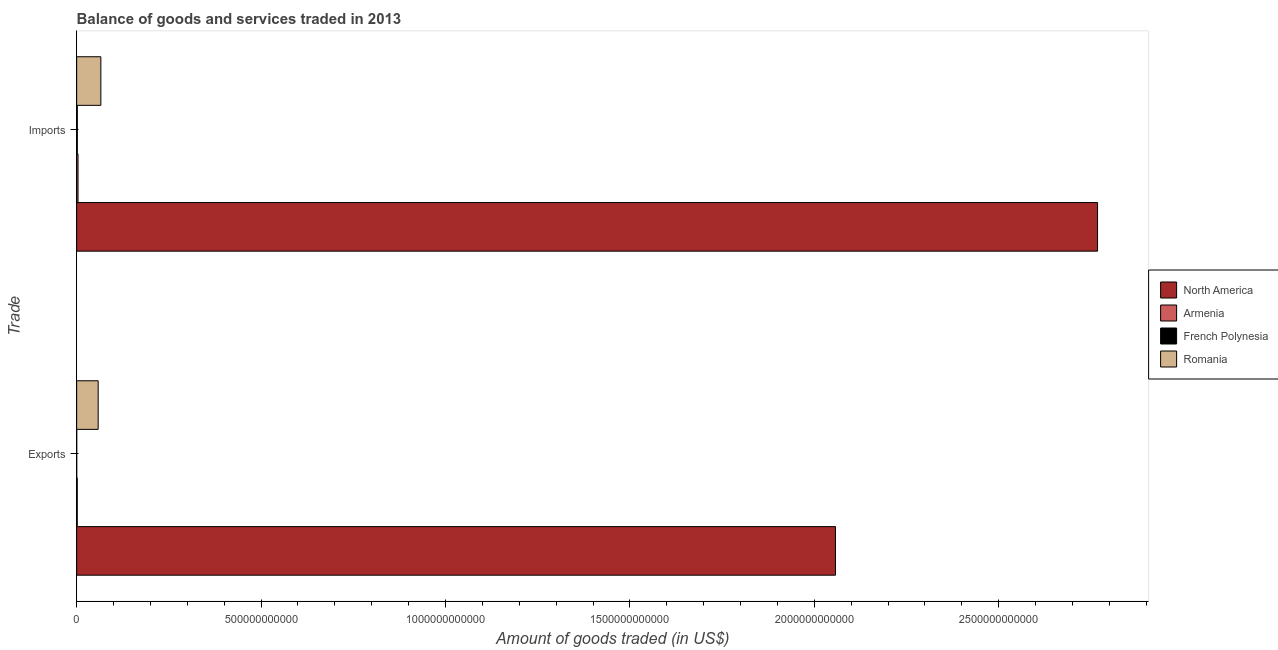Are the number of bars per tick equal to the number of legend labels?
Offer a very short reply. Yes. Are the number of bars on each tick of the Y-axis equal?
Your answer should be very brief. Yes. What is the label of the 2nd group of bars from the top?
Offer a very short reply. Exports. What is the amount of goods imported in Romania?
Offer a very short reply. 6.56e+1. Across all countries, what is the maximum amount of goods exported?
Provide a succinct answer. 2.06e+12. Across all countries, what is the minimum amount of goods exported?
Give a very brief answer. 1.50e+08. In which country was the amount of goods exported minimum?
Your answer should be very brief. French Polynesia. What is the total amount of goods imported in the graph?
Provide a succinct answer. 2.84e+12. What is the difference between the amount of goods exported in Romania and that in North America?
Provide a short and direct response. -2.00e+12. What is the difference between the amount of goods exported in Romania and the amount of goods imported in French Polynesia?
Your response must be concise. 5.65e+1. What is the average amount of goods exported per country?
Offer a very short reply. 5.29e+11. What is the difference between the amount of goods imported and amount of goods exported in Romania?
Make the answer very short. 7.24e+09. In how many countries, is the amount of goods imported greater than 1700000000000 US$?
Make the answer very short. 1. What is the ratio of the amount of goods imported in French Polynesia to that in Armenia?
Give a very brief answer. 0.48. What does the 2nd bar from the top in Imports represents?
Your answer should be compact. French Polynesia. How many bars are there?
Provide a short and direct response. 8. What is the difference between two consecutive major ticks on the X-axis?
Your response must be concise. 5.00e+11. Are the values on the major ticks of X-axis written in scientific E-notation?
Your response must be concise. No. Does the graph contain grids?
Provide a short and direct response. No. Where does the legend appear in the graph?
Ensure brevity in your answer.  Center right. How many legend labels are there?
Your answer should be very brief. 4. What is the title of the graph?
Make the answer very short. Balance of goods and services traded in 2013. What is the label or title of the X-axis?
Your answer should be very brief. Amount of goods traded (in US$). What is the label or title of the Y-axis?
Ensure brevity in your answer.  Trade. What is the Amount of goods traded (in US$) in North America in Exports?
Your answer should be very brief. 2.06e+12. What is the Amount of goods traded (in US$) in Armenia in Exports?
Keep it short and to the point. 1.64e+09. What is the Amount of goods traded (in US$) in French Polynesia in Exports?
Your response must be concise. 1.50e+08. What is the Amount of goods traded (in US$) in Romania in Exports?
Keep it short and to the point. 5.83e+1. What is the Amount of goods traded (in US$) of North America in Imports?
Offer a very short reply. 2.77e+12. What is the Amount of goods traded (in US$) in Armenia in Imports?
Offer a terse response. 3.73e+09. What is the Amount of goods traded (in US$) of French Polynesia in Imports?
Provide a succinct answer. 1.78e+09. What is the Amount of goods traded (in US$) of Romania in Imports?
Ensure brevity in your answer.  6.56e+1. Across all Trade, what is the maximum Amount of goods traded (in US$) in North America?
Provide a succinct answer. 2.77e+12. Across all Trade, what is the maximum Amount of goods traded (in US$) of Armenia?
Give a very brief answer. 3.73e+09. Across all Trade, what is the maximum Amount of goods traded (in US$) of French Polynesia?
Give a very brief answer. 1.78e+09. Across all Trade, what is the maximum Amount of goods traded (in US$) of Romania?
Offer a very short reply. 6.56e+1. Across all Trade, what is the minimum Amount of goods traded (in US$) of North America?
Your response must be concise. 2.06e+12. Across all Trade, what is the minimum Amount of goods traded (in US$) in Armenia?
Ensure brevity in your answer.  1.64e+09. Across all Trade, what is the minimum Amount of goods traded (in US$) of French Polynesia?
Ensure brevity in your answer.  1.50e+08. Across all Trade, what is the minimum Amount of goods traded (in US$) in Romania?
Offer a terse response. 5.83e+1. What is the total Amount of goods traded (in US$) in North America in the graph?
Your answer should be very brief. 4.83e+12. What is the total Amount of goods traded (in US$) of Armenia in the graph?
Give a very brief answer. 5.36e+09. What is the total Amount of goods traded (in US$) in French Polynesia in the graph?
Keep it short and to the point. 1.93e+09. What is the total Amount of goods traded (in US$) in Romania in the graph?
Your response must be concise. 1.24e+11. What is the difference between the Amount of goods traded (in US$) in North America in Exports and that in Imports?
Offer a terse response. -7.11e+11. What is the difference between the Amount of goods traded (in US$) in Armenia in Exports and that in Imports?
Make the answer very short. -2.09e+09. What is the difference between the Amount of goods traded (in US$) in French Polynesia in Exports and that in Imports?
Ensure brevity in your answer.  -1.63e+09. What is the difference between the Amount of goods traded (in US$) of Romania in Exports and that in Imports?
Offer a very short reply. -7.24e+09. What is the difference between the Amount of goods traded (in US$) in North America in Exports and the Amount of goods traded (in US$) in Armenia in Imports?
Make the answer very short. 2.05e+12. What is the difference between the Amount of goods traded (in US$) in North America in Exports and the Amount of goods traded (in US$) in French Polynesia in Imports?
Offer a very short reply. 2.06e+12. What is the difference between the Amount of goods traded (in US$) in North America in Exports and the Amount of goods traded (in US$) in Romania in Imports?
Ensure brevity in your answer.  1.99e+12. What is the difference between the Amount of goods traded (in US$) of Armenia in Exports and the Amount of goods traded (in US$) of French Polynesia in Imports?
Offer a terse response. -1.47e+08. What is the difference between the Amount of goods traded (in US$) of Armenia in Exports and the Amount of goods traded (in US$) of Romania in Imports?
Ensure brevity in your answer.  -6.39e+1. What is the difference between the Amount of goods traded (in US$) of French Polynesia in Exports and the Amount of goods traded (in US$) of Romania in Imports?
Offer a very short reply. -6.54e+1. What is the average Amount of goods traded (in US$) of North America per Trade?
Keep it short and to the point. 2.41e+12. What is the average Amount of goods traded (in US$) of Armenia per Trade?
Ensure brevity in your answer.  2.68e+09. What is the average Amount of goods traded (in US$) of French Polynesia per Trade?
Offer a very short reply. 9.66e+08. What is the average Amount of goods traded (in US$) in Romania per Trade?
Ensure brevity in your answer.  6.19e+1. What is the difference between the Amount of goods traded (in US$) in North America and Amount of goods traded (in US$) in Armenia in Exports?
Your answer should be compact. 2.06e+12. What is the difference between the Amount of goods traded (in US$) in North America and Amount of goods traded (in US$) in French Polynesia in Exports?
Make the answer very short. 2.06e+12. What is the difference between the Amount of goods traded (in US$) in North America and Amount of goods traded (in US$) in Romania in Exports?
Keep it short and to the point. 2.00e+12. What is the difference between the Amount of goods traded (in US$) in Armenia and Amount of goods traded (in US$) in French Polynesia in Exports?
Your answer should be very brief. 1.49e+09. What is the difference between the Amount of goods traded (in US$) in Armenia and Amount of goods traded (in US$) in Romania in Exports?
Provide a succinct answer. -5.67e+1. What is the difference between the Amount of goods traded (in US$) of French Polynesia and Amount of goods traded (in US$) of Romania in Exports?
Provide a short and direct response. -5.82e+1. What is the difference between the Amount of goods traded (in US$) in North America and Amount of goods traded (in US$) in Armenia in Imports?
Your answer should be very brief. 2.76e+12. What is the difference between the Amount of goods traded (in US$) in North America and Amount of goods traded (in US$) in French Polynesia in Imports?
Your response must be concise. 2.77e+12. What is the difference between the Amount of goods traded (in US$) in North America and Amount of goods traded (in US$) in Romania in Imports?
Provide a succinct answer. 2.70e+12. What is the difference between the Amount of goods traded (in US$) in Armenia and Amount of goods traded (in US$) in French Polynesia in Imports?
Make the answer very short. 1.95e+09. What is the difference between the Amount of goods traded (in US$) of Armenia and Amount of goods traded (in US$) of Romania in Imports?
Give a very brief answer. -6.18e+1. What is the difference between the Amount of goods traded (in US$) of French Polynesia and Amount of goods traded (in US$) of Romania in Imports?
Your answer should be compact. -6.38e+1. What is the ratio of the Amount of goods traded (in US$) of North America in Exports to that in Imports?
Offer a very short reply. 0.74. What is the ratio of the Amount of goods traded (in US$) in Armenia in Exports to that in Imports?
Give a very brief answer. 0.44. What is the ratio of the Amount of goods traded (in US$) of French Polynesia in Exports to that in Imports?
Offer a very short reply. 0.08. What is the ratio of the Amount of goods traded (in US$) of Romania in Exports to that in Imports?
Offer a very short reply. 0.89. What is the difference between the highest and the second highest Amount of goods traded (in US$) in North America?
Provide a short and direct response. 7.11e+11. What is the difference between the highest and the second highest Amount of goods traded (in US$) in Armenia?
Your response must be concise. 2.09e+09. What is the difference between the highest and the second highest Amount of goods traded (in US$) of French Polynesia?
Ensure brevity in your answer.  1.63e+09. What is the difference between the highest and the second highest Amount of goods traded (in US$) in Romania?
Offer a terse response. 7.24e+09. What is the difference between the highest and the lowest Amount of goods traded (in US$) in North America?
Offer a very short reply. 7.11e+11. What is the difference between the highest and the lowest Amount of goods traded (in US$) in Armenia?
Make the answer very short. 2.09e+09. What is the difference between the highest and the lowest Amount of goods traded (in US$) of French Polynesia?
Keep it short and to the point. 1.63e+09. What is the difference between the highest and the lowest Amount of goods traded (in US$) in Romania?
Your answer should be very brief. 7.24e+09. 